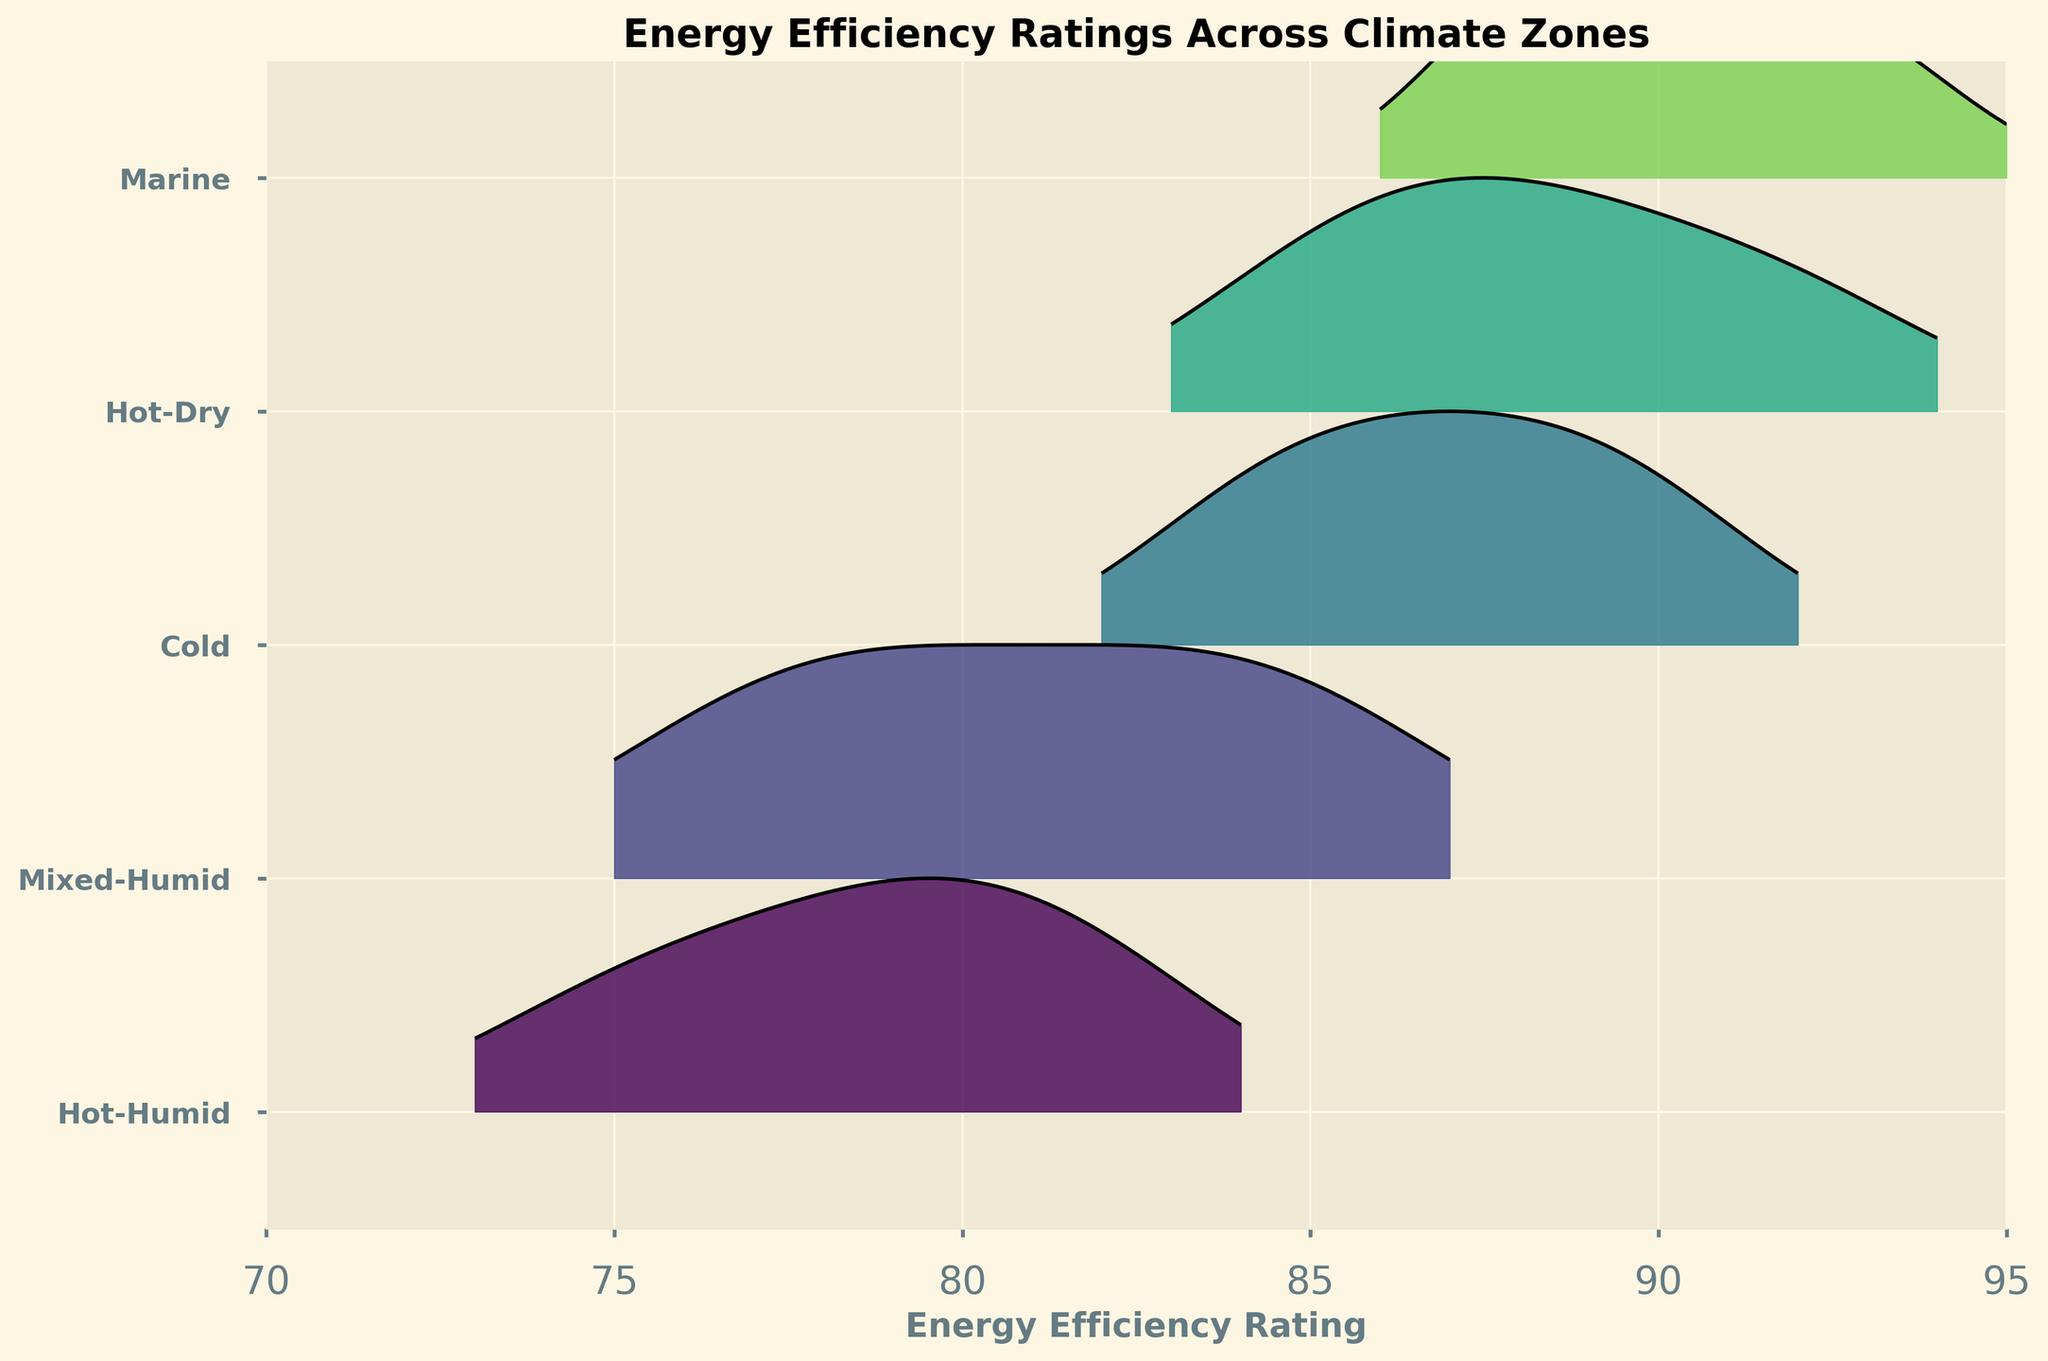What is the title of the plot? The title of the plot is displayed at the top center portion of the figure. It summarizes the main content or purpose of the figure.
Answer: Energy Efficiency Ratings Across Climate Zones How many climate zones are represented in the plot? To find the number of climate zones represented, count the distinct labeled ticks on the y-axis of the plot.
Answer: 5 Which climate zone has the highest peak in the ridgeline plot? Identify the ridgeline with the highest peak by comparing the vertical extent of each curve. The highest peak indicates the climate zone with the highest density around certain energy ratings.
Answer: Marine How does the range of energy efficiency ratings in the Cold zone compare to the Hot-Humid zone? Compare the minimum and maximum points of the x-range covered by the ridgeline curves for both the Cold and Hot-Humid climate zones.
Answer: The Cold zone ranges roughly from 84 to 90, while the Hot-Humid zone ranges from 75 to 82 What is the general shape of the ridgeline plot for the Hot-Dry climate zone? Observe the shape of the ridgeline curve specific to the Hot-Dry climate zone to describe its distribution (e.g., unimodal, skewed).
Answer: Unimodal and moderately spread Which climate zone shows the least variation in energy efficiency ratings? Identify the climate zone with the narrowest spread along the x-axis by examining the width of the ridgeline curves.
Answer: Cold Which climate zones have overlapping distributions in their energy efficiency ratings? Look for regions where the ridgeline curves of different climate zones overlap along the x-axis to determine which zones have similar distributions.
Answer: Marine and Cold What can be inferred about the energy efficiency of buildings in the Marine climate zone based on the ridgeline plot? Analyze the peak and spread of the Marine zone's ridgeline to infer the general distribution and concentration of energy efficiency ratings.
Answer: High efficiency, with ratings mainly between 88 and 93 How does the median energy efficiency rating in the Mixed-Humid zone compare with that in the Hot-Dry zone? Approximate the median by finding the center of the distribution curve for both zones, considering the peaks and shapes of the ridgelines.
Answer: Mixed-Humid around 81, Hot-Dry around 88 